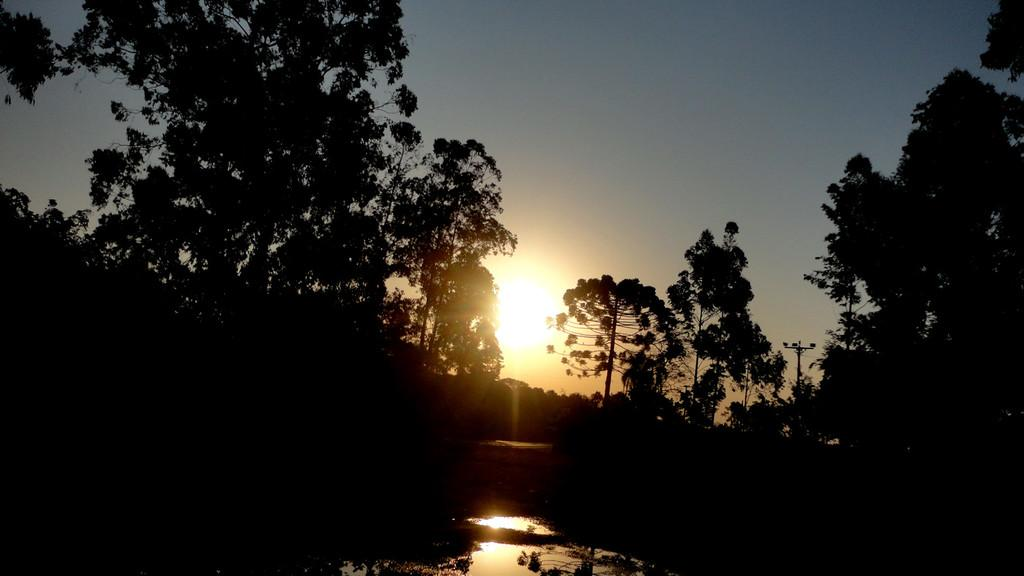What type of vegetation can be seen in the image? There are trees in the image. What time of day is depicted in the image? The image depicts a sunset. What part of the natural environment is visible in the image? The sky is visible in the image. How would you describe the lighting in the image? The image is described as being very dark. What song is being played during the sunset in the image? There is no information about a song being played in the image, as it only depicts a sunset and trees. 